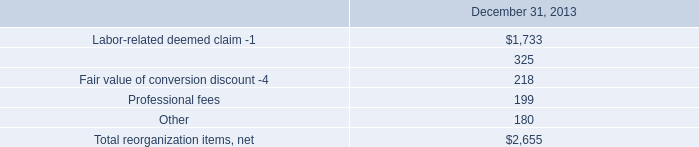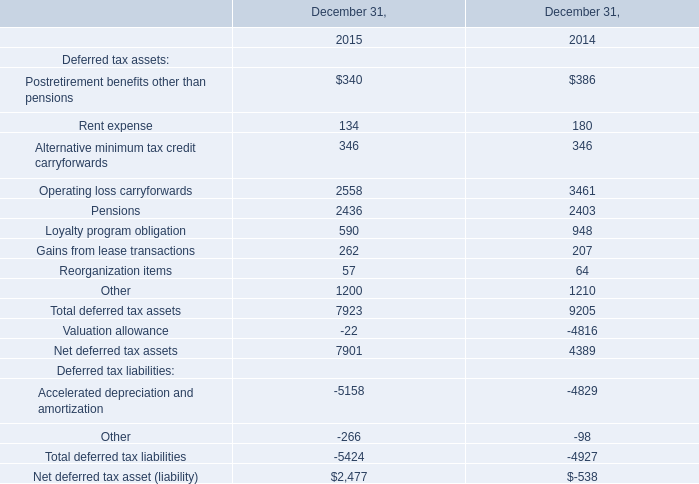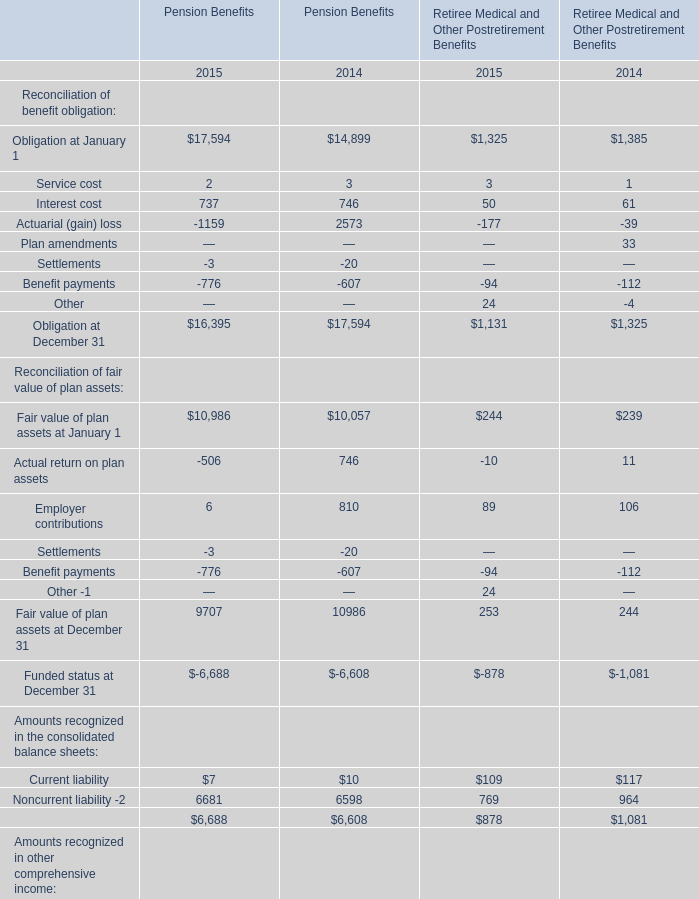In which year is actual return on plan assets positive? 
Answer: 2014. 